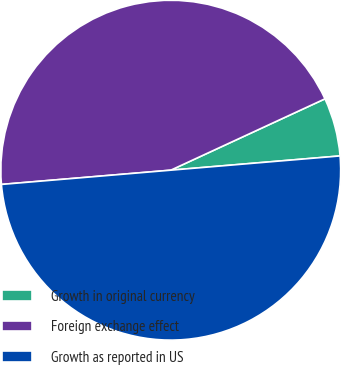Convert chart to OTSL. <chart><loc_0><loc_0><loc_500><loc_500><pie_chart><fcel>Growth in original currency<fcel>Foreign exchange effect<fcel>Growth as reported in US<nl><fcel>5.56%<fcel>44.44%<fcel>50.0%<nl></chart> 